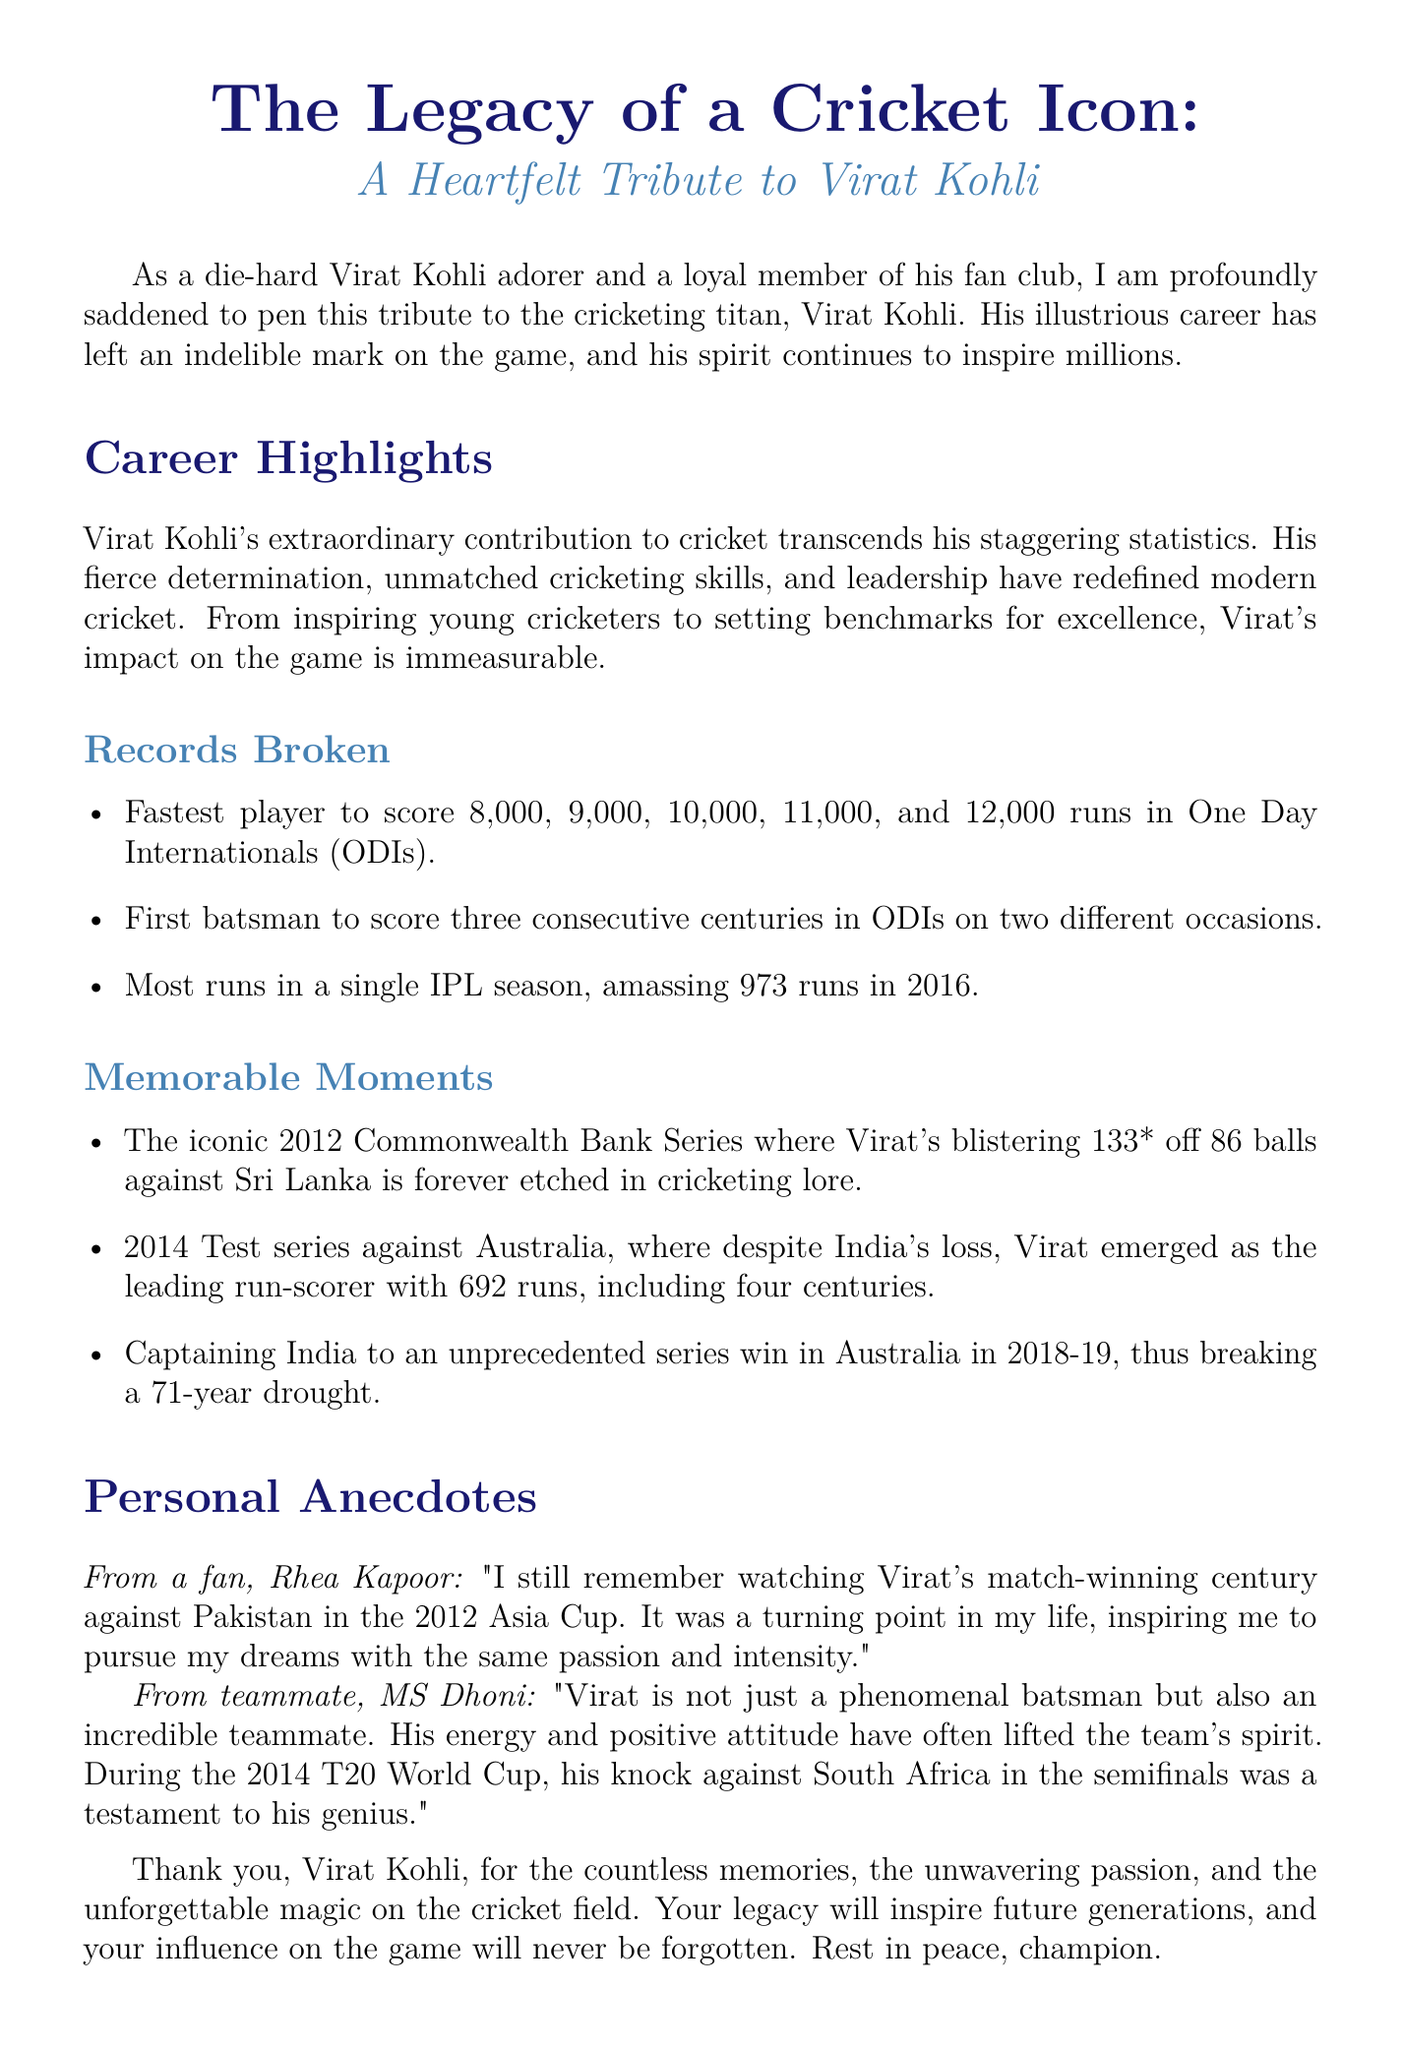What is the title of the tribute? The title of the tribute is the main heading of the document, highlighting the subject and nature of the article.
Answer: The Legacy of a Cricket Icon Who is the tribute dedicated to? The tribute specifically addresses a prominent figure in cricket, making the focus clear.
Answer: Virat Kohli What year did Virat score 973 runs in the IPL? The document mentions a significant achievement during a specific IPL season, which is relevant to his career highlights.
Answer: 2016 Which series did Kohli lead India to victory in Australia? This question pertains to a specific achievement in Kohli's captaincy, showcasing a key moment in his career.
Answer: 2018-19 How many runs did Virat score in the 2014 Test series against Australia? The question concerns a specific performance during an important series, demonstrating his skill as a batsman.
Answer: 692 runs Who mentioned a match-winning century against Pakistan? This question focuses on a personal anecdote shared about the impact of Kohli's performance.
Answer: Rhea Kapoor What is described as a turning point in a fan's life? The document includes a personal story that emphasizes the emotional connection fans have with Kohli's cricketing moments.
Answer: Virat's match-winning century against Pakistan What was Virat's score against Sri Lanka in the 2012 Commonwealth Bank Series? This specific performance is noted as an iconic moment in his career.
Answer: 133* What emotion is primarily reflected in this tribute? The overall sentiment of the document can be summarized to capture the essence of the tribute conveyed.
Answer: Heartfelt 